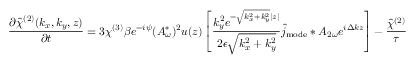Convert formula to latex. <formula><loc_0><loc_0><loc_500><loc_500>\frac { \partial \hat { \chi } ^ { ( 2 ) } ( k _ { x } , k _ { y } , z ) } { \partial t } = 3 \chi ^ { ( 3 ) } \beta e ^ { - i \psi } ( A _ { \omega } ^ { * } ) ^ { 2 } u ( z ) \left [ \frac { k _ { y } ^ { 2 } e ^ { - \sqrt { k _ { x } ^ { 2 } + k _ { y } ^ { 2 } } | z | } } { 2 \epsilon \sqrt { k _ { x } ^ { 2 } + k _ { y } ^ { 2 } } } \hat { j } _ { m o d e } \ast A _ { 2 \omega } e ^ { i \Delta k z } \right ] - \frac { \hat { \chi } ^ { ( 2 ) } } { \tau }</formula> 